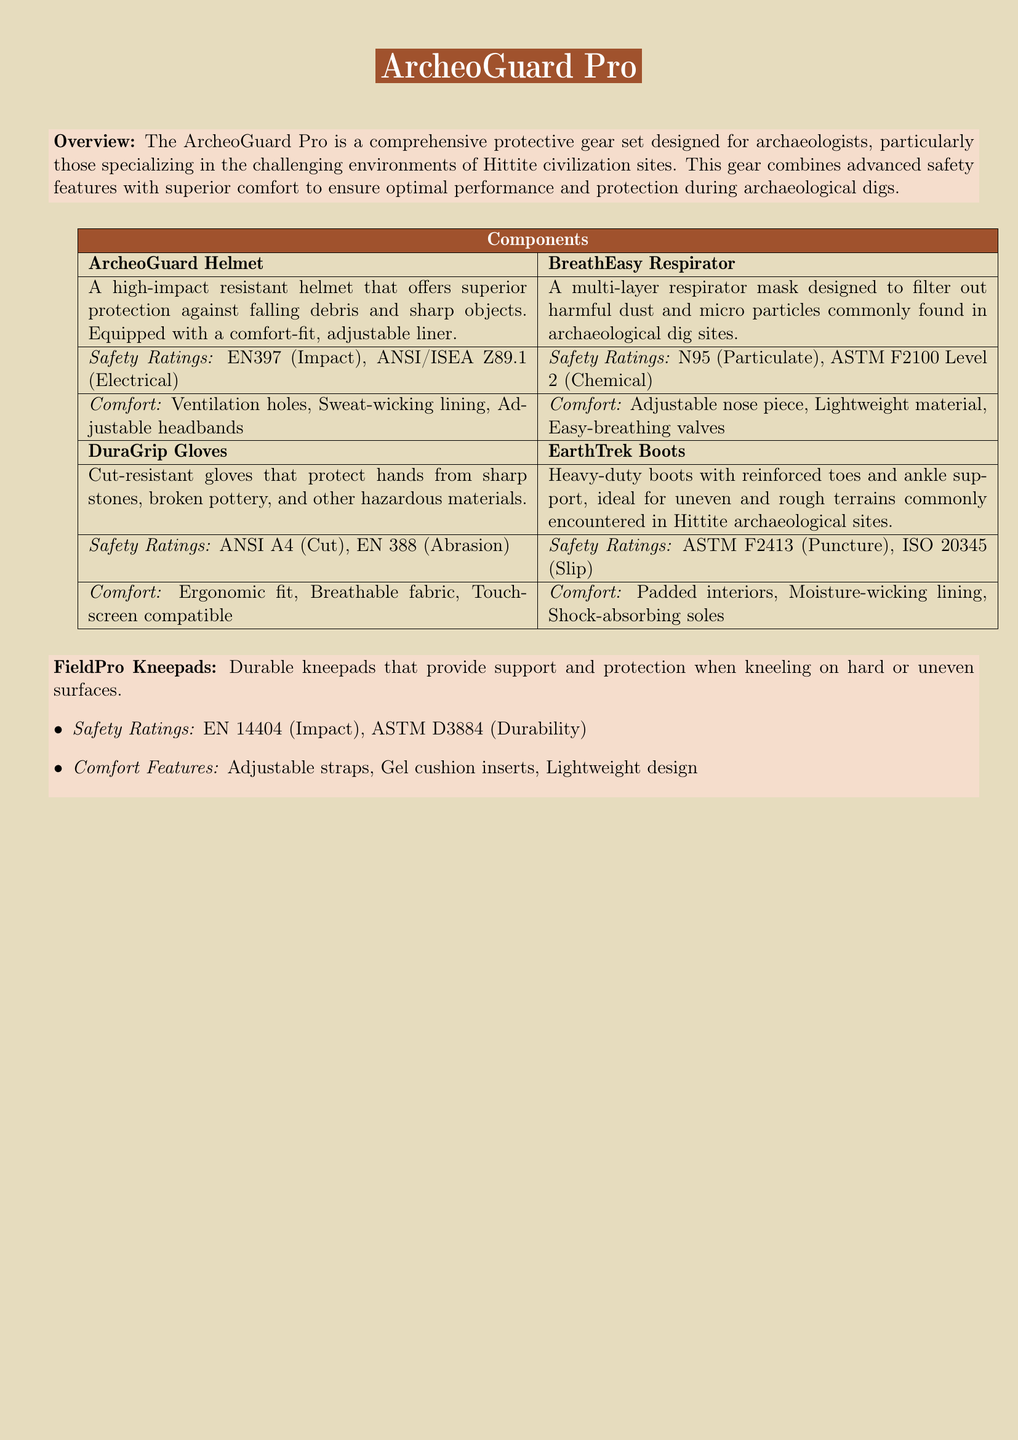What is the product name? The product name is clearly stated in the title of the document as "ArcheoGuard Pro."
Answer: ArcheoGuard Pro What are the safety ratings for the ArcheoGuard Helmet? The safety ratings for the ArcheoGuard Helmet are listed in the document as EN397 (Impact) and ANSI/ISEA Z89.1 (Electrical).
Answer: EN397, ANSI/ISEA Z89.1 What materials are the DuraGrip Gloves made from? The DuraGrip Gloves are characterized by being cut-resistant, indicating that they are made from durable materials designed to withstand cuts.
Answer: Cut-resistant What comfort feature is highlighted for the BreathEasy Respirator? The BreathEasy Respirator is designed with an adjustable nose piece as a key comfort feature mentioned in the document.
Answer: Adjustable nose piece What type of protection do the EarthTrek Boots offer? The EarthTrek Boots provide protection against punctures and slips based on the specified safety ratings.
Answer: Puncture, Slip What is a feature of the FieldPro Kneepads? The FieldPro Kneepads are equipped with gel cushion inserts, enhancing their comfort and support when kneeling.
Answer: Gel cushion inserts Which component has a breathable fabric? The DuraGrip Gloves are described as having a breathable fabric, making them comfortable for use during archaeological digs.
Answer: DuraGrip Gloves What is the primary purpose of the ArcheoGuard Pro gear? The ArcheoGuard Pro gear is designed to provide comprehensive protection for archaeologists during digs, specifically at Hittite civilization sites.
Answer: Comprehensive protection How is the fit of the ArcheoGuard Helmet described? The fit of the ArcheoGuard Helmet is described as comfort-fit, with an adjustable liner for better adaptation to the user.
Answer: Comfort-fit, adjustable liner 